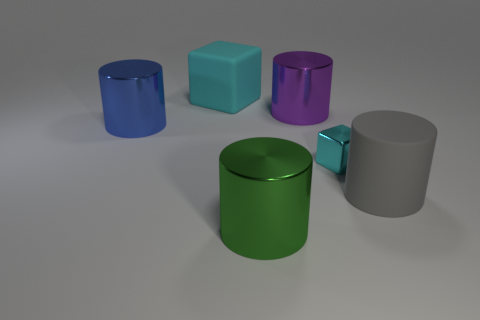Subtract all gray rubber cylinders. How many cylinders are left? 3 Subtract all blue cylinders. How many cylinders are left? 3 Subtract all cylinders. How many objects are left? 2 Add 1 blue metallic things. How many objects exist? 7 Subtract 1 blocks. How many blocks are left? 1 Add 5 cyan shiny objects. How many cyan shiny objects are left? 6 Add 3 big yellow cylinders. How many big yellow cylinders exist? 3 Subtract 1 green cylinders. How many objects are left? 5 Subtract all purple cubes. Subtract all cyan balls. How many cubes are left? 2 Subtract all tiny brown metallic cylinders. Subtract all small objects. How many objects are left? 5 